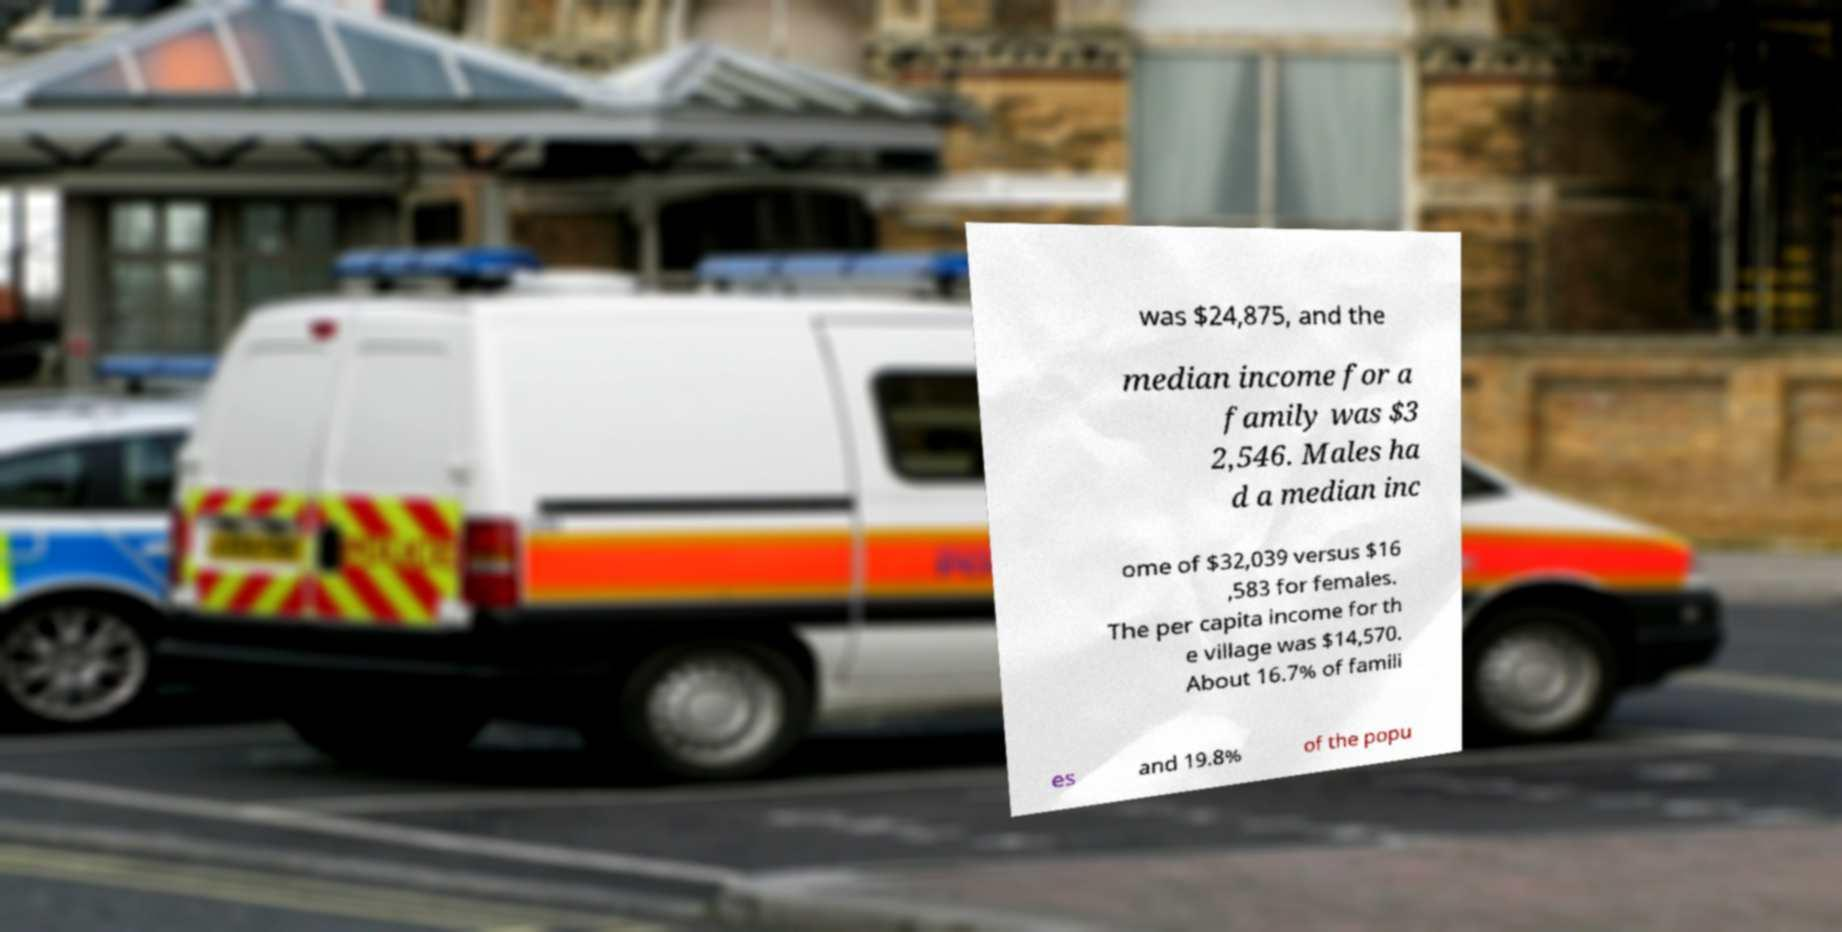I need the written content from this picture converted into text. Can you do that? was $24,875, and the median income for a family was $3 2,546. Males ha d a median inc ome of $32,039 versus $16 ,583 for females. The per capita income for th e village was $14,570. About 16.7% of famili es and 19.8% of the popu 